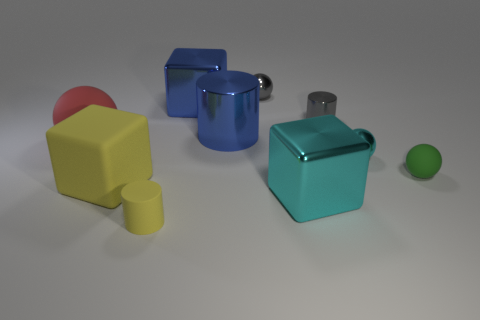Subtract all cubes. How many objects are left? 7 Subtract all rubber objects. Subtract all red balls. How many objects are left? 5 Add 4 big cyan objects. How many big cyan objects are left? 5 Add 8 big yellow matte blocks. How many big yellow matte blocks exist? 9 Subtract 0 cyan cylinders. How many objects are left? 10 